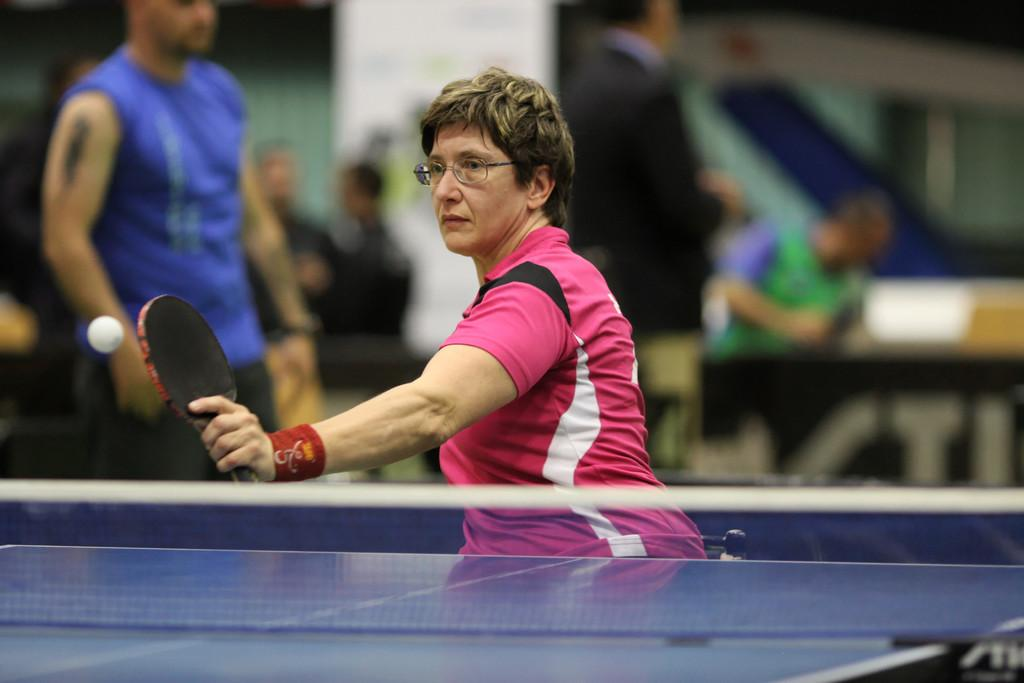What activity is the lady in the image engaged in? The lady in the image is playing table tennis. Can you describe the people in the background of the image? There are people sitting on a table in the background of the image. What type of writing can be seen on the table tennis paddle in the image? There is no writing visible on the table tennis paddle in the image. What song is being sung by the lady playing table tennis in the image? The lady playing table tennis is not singing a song in the image. 